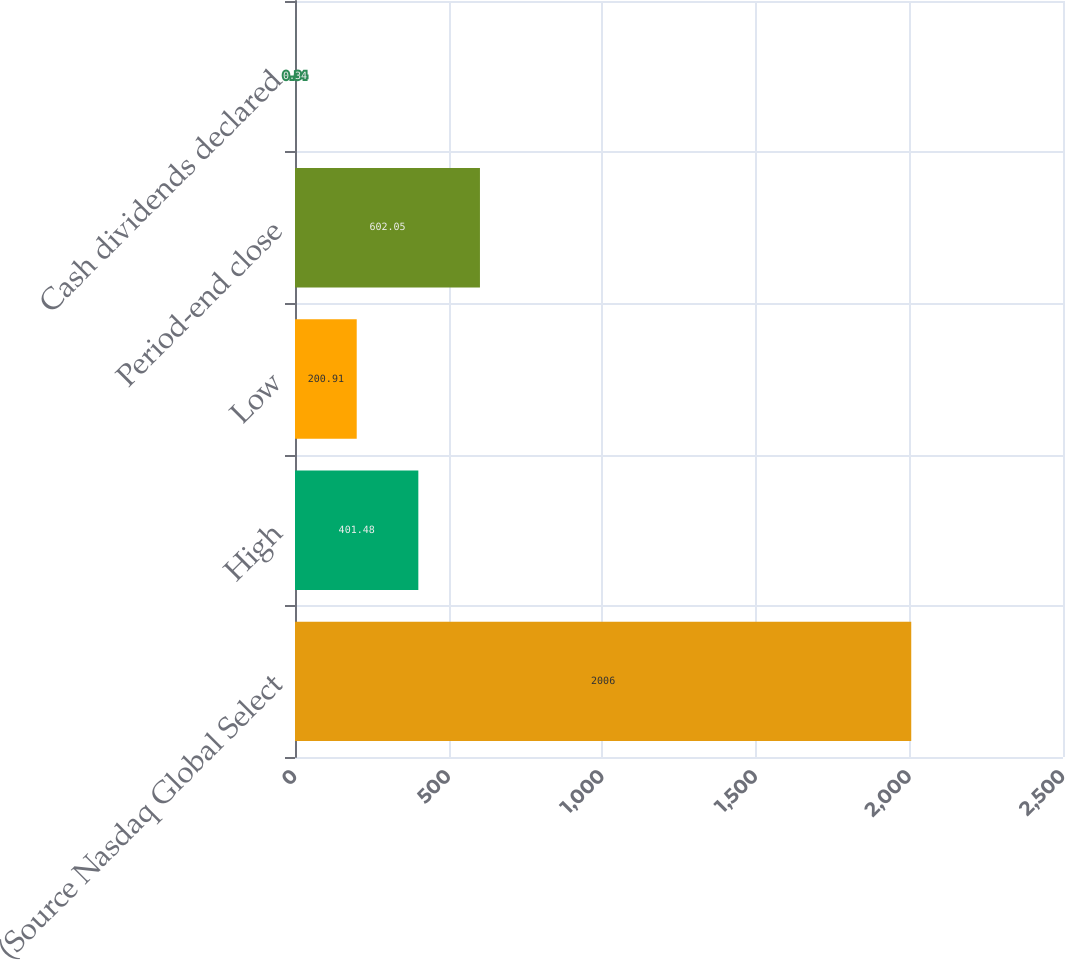Convert chart to OTSL. <chart><loc_0><loc_0><loc_500><loc_500><bar_chart><fcel>(Source Nasdaq Global Select<fcel>High<fcel>Low<fcel>Period-end close<fcel>Cash dividends declared<nl><fcel>2006<fcel>401.48<fcel>200.91<fcel>602.05<fcel>0.34<nl></chart> 